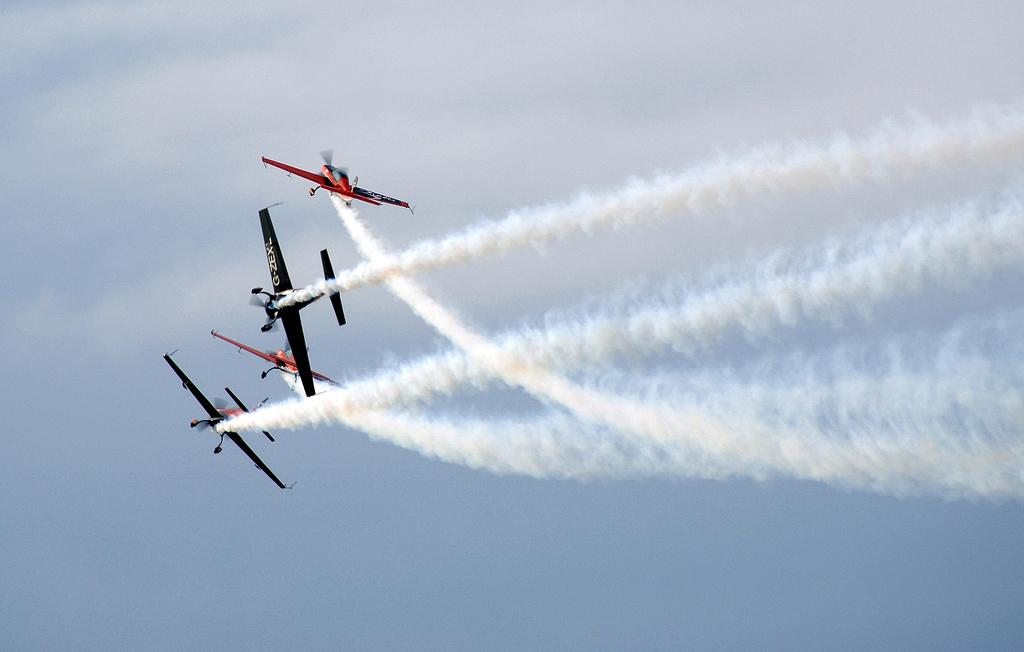What is the main subject of the image? The main subject of the image is aircraft. What colors are the aircraft in the image? The aircraft are in black and red color. What can be seen in the background of the image? The sky is visible in the background of the image. What colors are present in the sky in the image? The sky is in blue and white color. What type of machine can be seen operating in the image? There is no machine operating in the image; it features aircraft in black and red color with a blue and white sky in the background. How many cars are visible in the image? There are no cars present in the image; it features aircraft and a sky. 